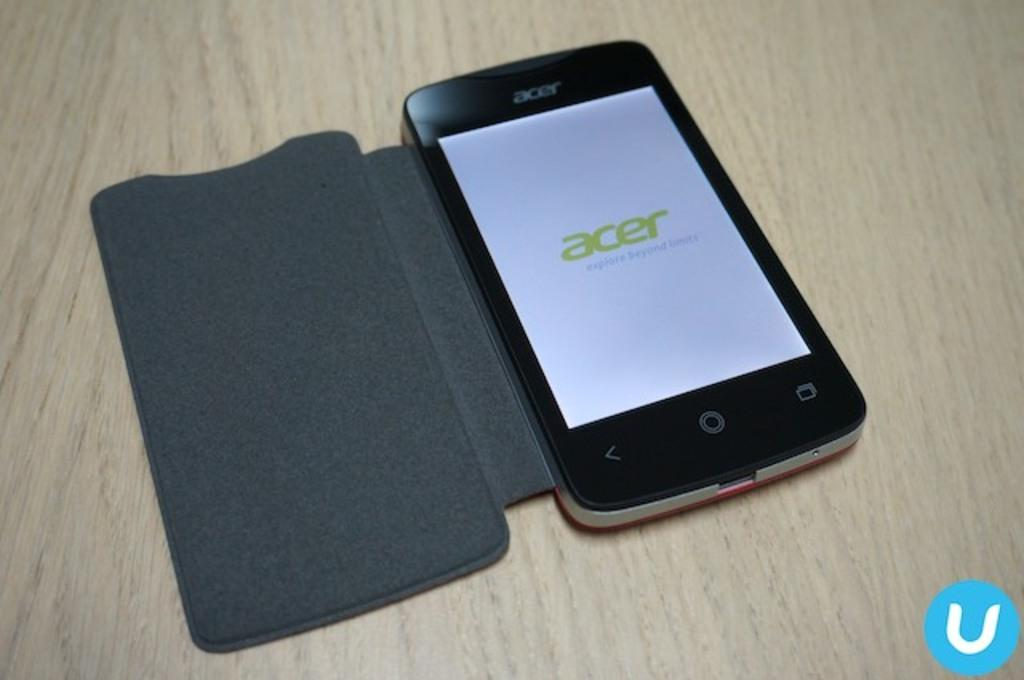<image>
Give a short and clear explanation of the subsequent image. An acer phone in a protective case is on a light colored wooden surface. 